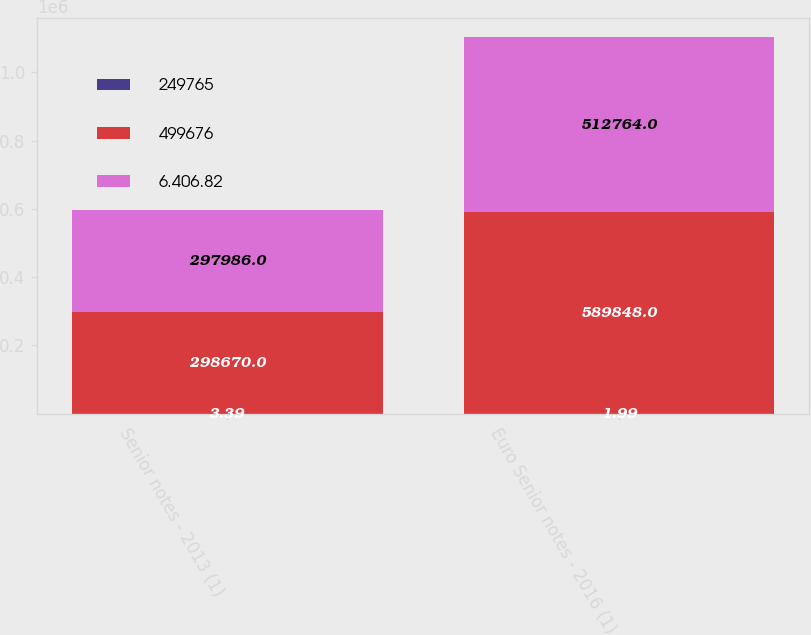Convert chart to OTSL. <chart><loc_0><loc_0><loc_500><loc_500><stacked_bar_chart><ecel><fcel>Senior notes - 2013 (1)<fcel>Euro Senior notes - 2016 (1)<nl><fcel>249765<fcel>3.39<fcel>1.99<nl><fcel>499676<fcel>298670<fcel>589848<nl><fcel>6.406.82<fcel>297986<fcel>512764<nl></chart> 